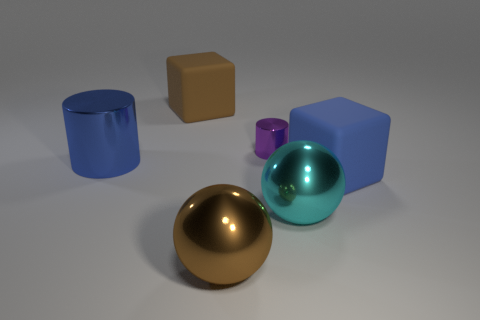Subtract all purple cylinders. How many cylinders are left? 1 Subtract all cubes. How many objects are left? 4 Add 2 large cylinders. How many objects exist? 8 Subtract 0 green balls. How many objects are left? 6 Subtract 2 spheres. How many spheres are left? 0 Subtract all red cylinders. Subtract all yellow spheres. How many cylinders are left? 2 Subtract all gray cylinders. How many blue cubes are left? 1 Subtract all large shiny things. Subtract all blue objects. How many objects are left? 1 Add 6 big brown balls. How many big brown balls are left? 7 Add 6 brown shiny balls. How many brown shiny balls exist? 7 